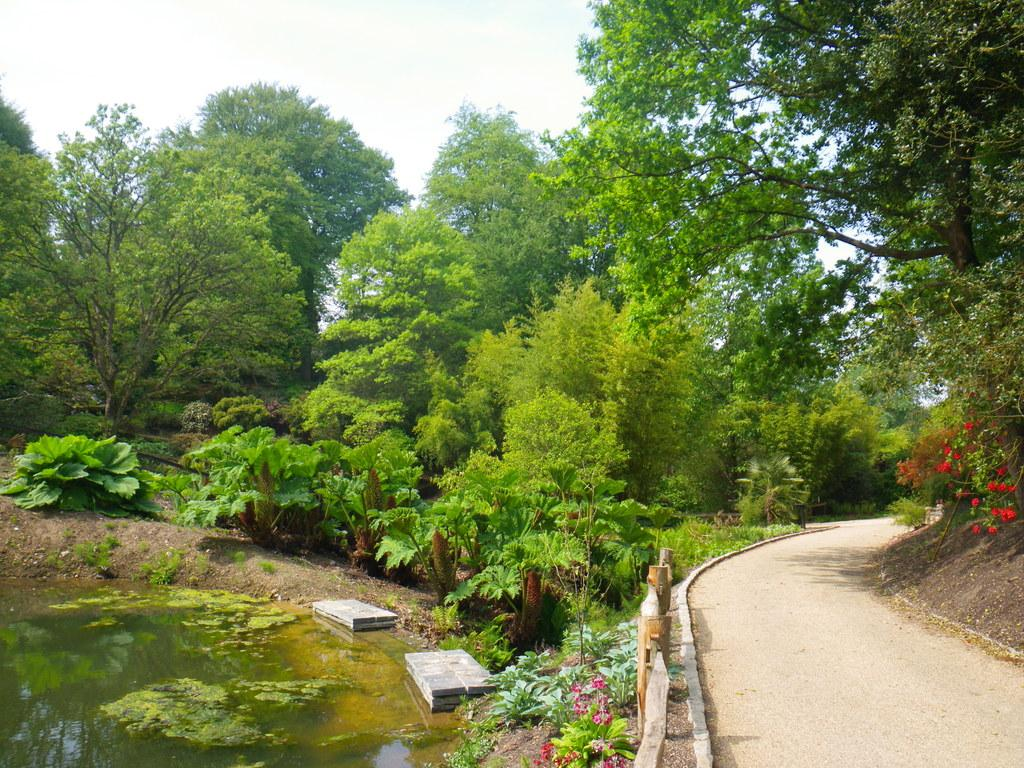What can be seen on the left side of the image? There is water on the left side of the image. What is located in the middle of the image? There are trees in the middle of the image. What is on the right side of the image? There is a way on the right side of the image. What is visible at the top of the image? The sky is visible at the top of the image. Is there a book on the trees in the image? There is no book present in the image; it features water, trees, and a way. What act is being performed by the trees in the image? The trees are not performing any act in the image; they are stationary and not capable of performing acts. 